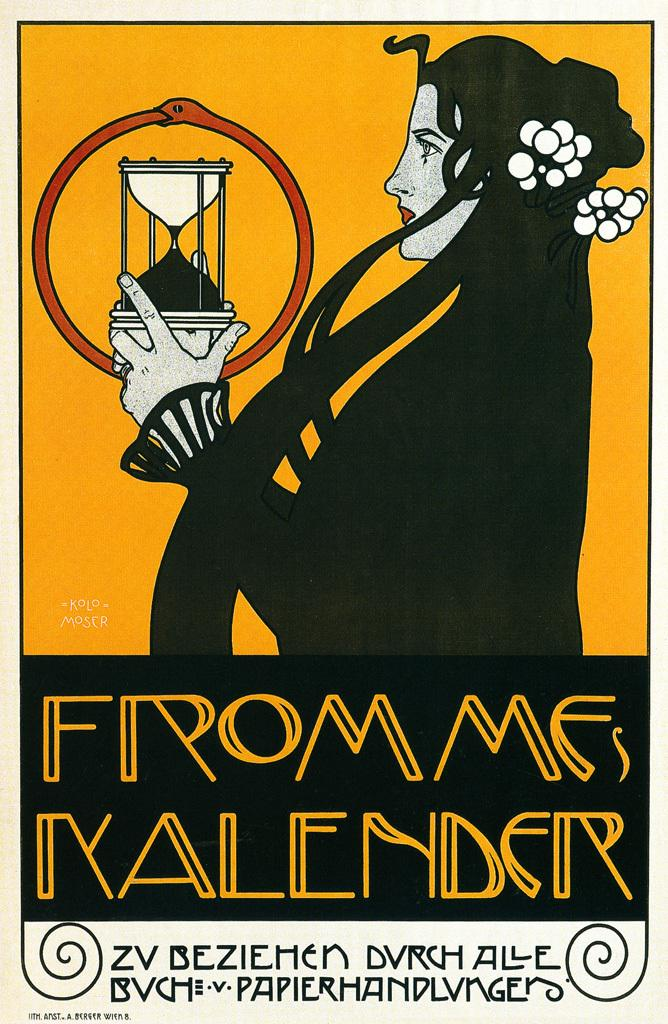Provide a one-sentence caption for the provided image. The cover from Frommes Kalender has a woman on it. 